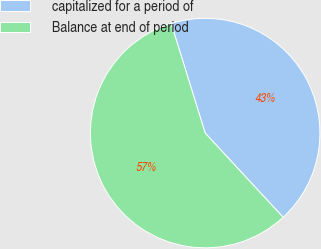<chart> <loc_0><loc_0><loc_500><loc_500><pie_chart><fcel>capitalized for a period of<fcel>Balance at end of period<nl><fcel>42.9%<fcel>57.1%<nl></chart> 